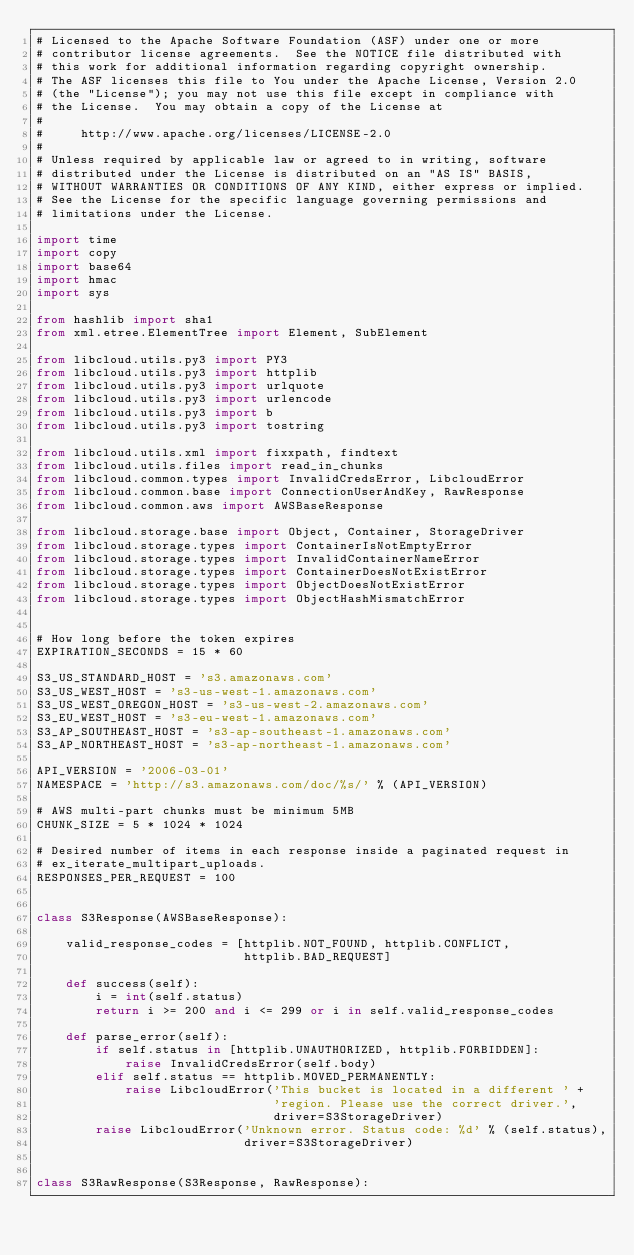Convert code to text. <code><loc_0><loc_0><loc_500><loc_500><_Python_># Licensed to the Apache Software Foundation (ASF) under one or more
# contributor license agreements.  See the NOTICE file distributed with
# this work for additional information regarding copyright ownership.
# The ASF licenses this file to You under the Apache License, Version 2.0
# (the "License"); you may not use this file except in compliance with
# the License.  You may obtain a copy of the License at
#
#     http://www.apache.org/licenses/LICENSE-2.0
#
# Unless required by applicable law or agreed to in writing, software
# distributed under the License is distributed on an "AS IS" BASIS,
# WITHOUT WARRANTIES OR CONDITIONS OF ANY KIND, either express or implied.
# See the License for the specific language governing permissions and
# limitations under the License.

import time
import copy
import base64
import hmac
import sys

from hashlib import sha1
from xml.etree.ElementTree import Element, SubElement

from libcloud.utils.py3 import PY3
from libcloud.utils.py3 import httplib
from libcloud.utils.py3 import urlquote
from libcloud.utils.py3 import urlencode
from libcloud.utils.py3 import b
from libcloud.utils.py3 import tostring

from libcloud.utils.xml import fixxpath, findtext
from libcloud.utils.files import read_in_chunks
from libcloud.common.types import InvalidCredsError, LibcloudError
from libcloud.common.base import ConnectionUserAndKey, RawResponse
from libcloud.common.aws import AWSBaseResponse

from libcloud.storage.base import Object, Container, StorageDriver
from libcloud.storage.types import ContainerIsNotEmptyError
from libcloud.storage.types import InvalidContainerNameError
from libcloud.storage.types import ContainerDoesNotExistError
from libcloud.storage.types import ObjectDoesNotExistError
from libcloud.storage.types import ObjectHashMismatchError


# How long before the token expires
EXPIRATION_SECONDS = 15 * 60

S3_US_STANDARD_HOST = 's3.amazonaws.com'
S3_US_WEST_HOST = 's3-us-west-1.amazonaws.com'
S3_US_WEST_OREGON_HOST = 's3-us-west-2.amazonaws.com'
S3_EU_WEST_HOST = 's3-eu-west-1.amazonaws.com'
S3_AP_SOUTHEAST_HOST = 's3-ap-southeast-1.amazonaws.com'
S3_AP_NORTHEAST_HOST = 's3-ap-northeast-1.amazonaws.com'

API_VERSION = '2006-03-01'
NAMESPACE = 'http://s3.amazonaws.com/doc/%s/' % (API_VERSION)

# AWS multi-part chunks must be minimum 5MB
CHUNK_SIZE = 5 * 1024 * 1024

# Desired number of items in each response inside a paginated request in
# ex_iterate_multipart_uploads.
RESPONSES_PER_REQUEST = 100


class S3Response(AWSBaseResponse):

    valid_response_codes = [httplib.NOT_FOUND, httplib.CONFLICT,
                            httplib.BAD_REQUEST]

    def success(self):
        i = int(self.status)
        return i >= 200 and i <= 299 or i in self.valid_response_codes

    def parse_error(self):
        if self.status in [httplib.UNAUTHORIZED, httplib.FORBIDDEN]:
            raise InvalidCredsError(self.body)
        elif self.status == httplib.MOVED_PERMANENTLY:
            raise LibcloudError('This bucket is located in a different ' +
                                'region. Please use the correct driver.',
                                driver=S3StorageDriver)
        raise LibcloudError('Unknown error. Status code: %d' % (self.status),
                            driver=S3StorageDriver)


class S3RawResponse(S3Response, RawResponse):</code> 